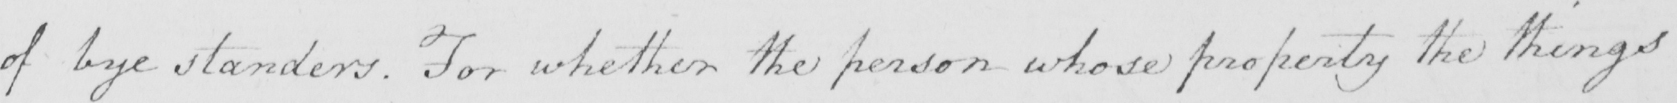Please provide the text content of this handwritten line. of bye standers . For whether the person whose property the things 